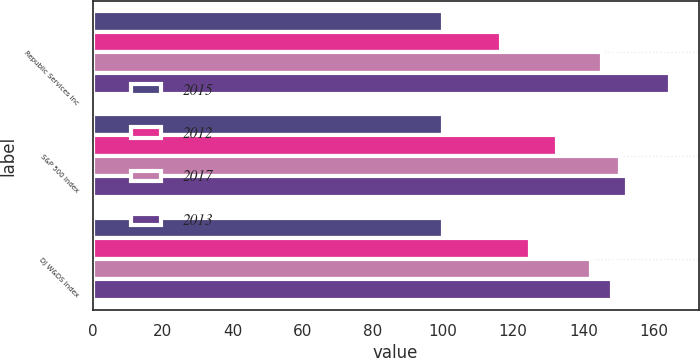Convert chart to OTSL. <chart><loc_0><loc_0><loc_500><loc_500><stacked_bar_chart><ecel><fcel>Republic Services Inc<fcel>S&P 500 Index<fcel>DJ W&DS Index<nl><fcel>2015<fcel>100<fcel>100<fcel>100<nl><fcel>2012<fcel>116.62<fcel>132.39<fcel>124.94<nl><fcel>2017<fcel>145.48<fcel>150.51<fcel>142.12<nl><fcel>2013<fcel>164.71<fcel>152.59<fcel>148.07<nl></chart> 